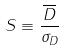Convert formula to latex. <formula><loc_0><loc_0><loc_500><loc_500>S \equiv \frac { \overline { D } } { \sigma _ { D } }</formula> 